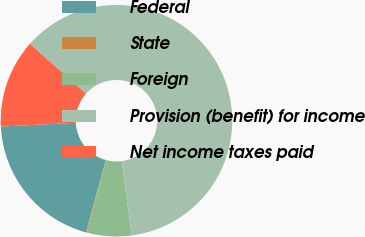Convert chart. <chart><loc_0><loc_0><loc_500><loc_500><pie_chart><fcel>Federal<fcel>State<fcel>Foreign<fcel>Provision (benefit) for income<fcel>Net income taxes paid<nl><fcel>19.95%<fcel>0.11%<fcel>6.23%<fcel>61.35%<fcel>12.36%<nl></chart> 